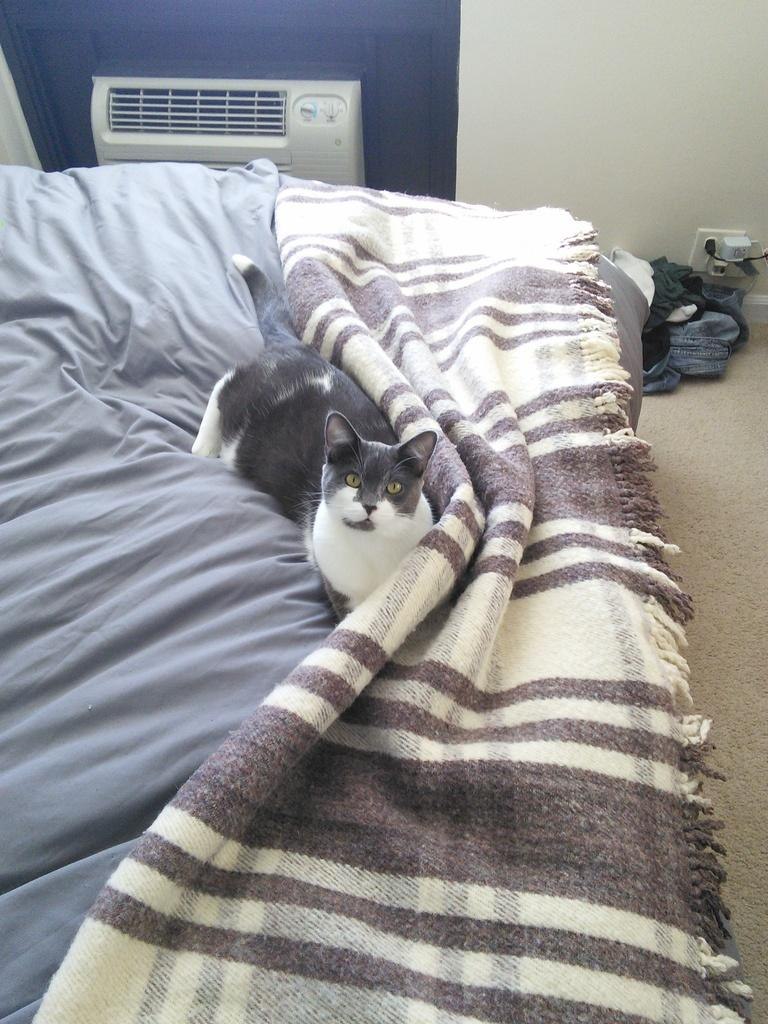What type of animal is on the bed in the image? There is a cat on the bed in the image. What device is visible in the image for cooling the air? There is an air cooler in the image. Where is the air cooler located in the image? The air cooler is on the top left side of the image. How many crows are sitting on the air cooler in the image? There are no crows present in the image; it only features a cat on the bed and an air cooler on the top left side. What type of beetle can be seen crawling on the fifth item in the image? There is no fifth item in the image, and no beetle is present. 